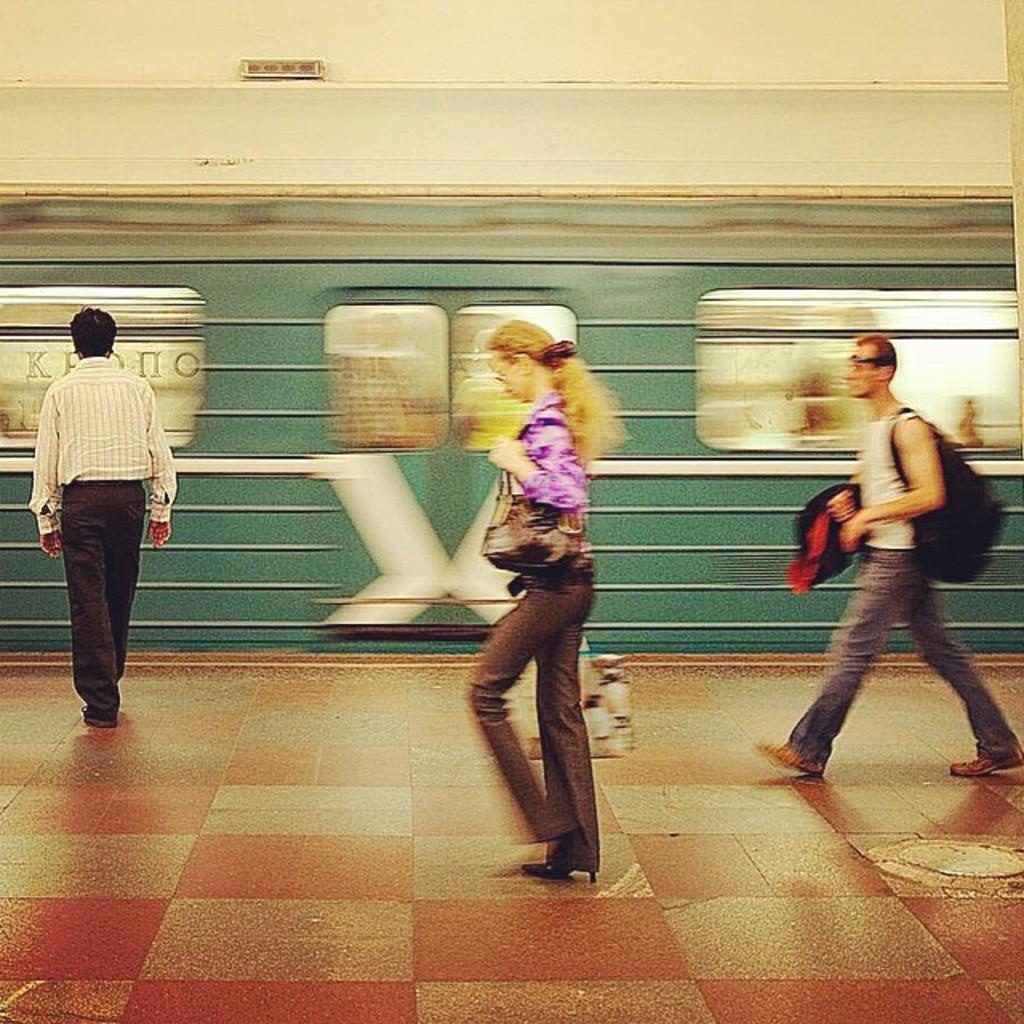What are the people in the image doing? The people in the image are walking. Can you describe what some of the people are carrying? Some of the people are wearing bags. What can be seen in the background of the image? There appears to be a train in the background of the image. Where is the faucet located in the image? There is no faucet present in the image. What type of trail are the people walking on in the image? The image does not show a trail; it only shows people walking and a train in the background. 